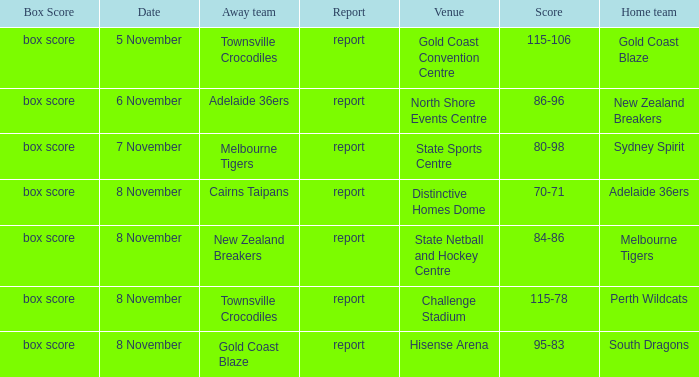Who was the home team at Gold Coast Convention Centre? Gold Coast Blaze. 